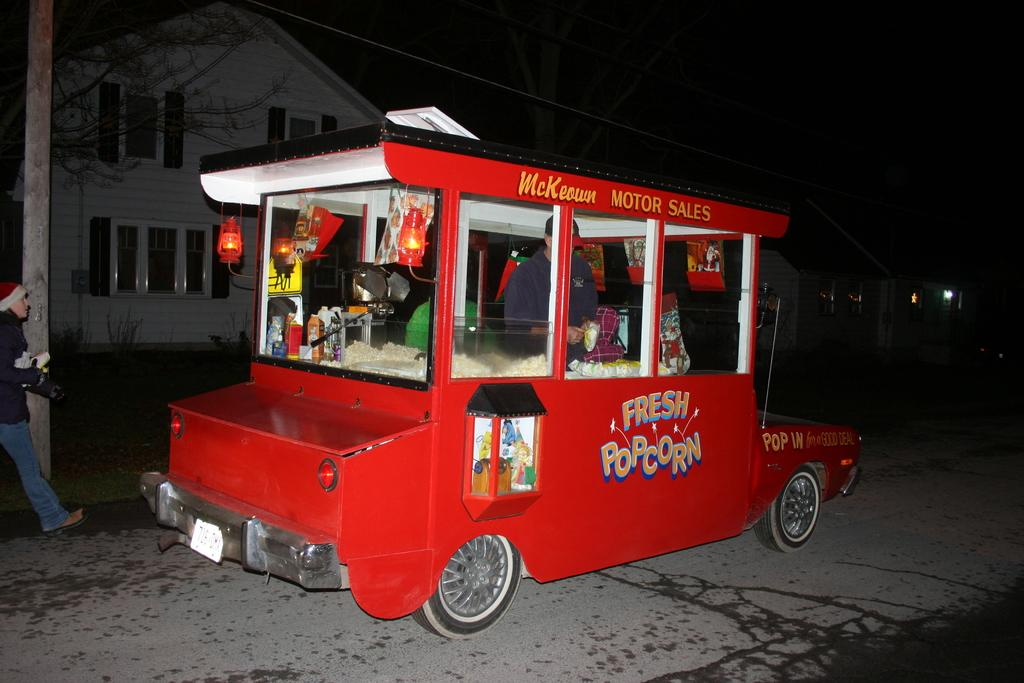What is the person with in the image? There is a person with a vehicle in the image. What is the vehicle doing in the image? The vehicle is moving on the road. What type of structure can be seen in the image? There is a house visible in the image. What type of vegetation is present in the image? There are trees in the image. What is another person doing in the image? A person is walking beside the road. What type of record is being played by the person walking beside the road? There is no record or any indication of music playing in the image. What type of whip is being used by the person driving the vehicle? There is no whip present in the image, and vehicles do not typically use whips for propulsion. 